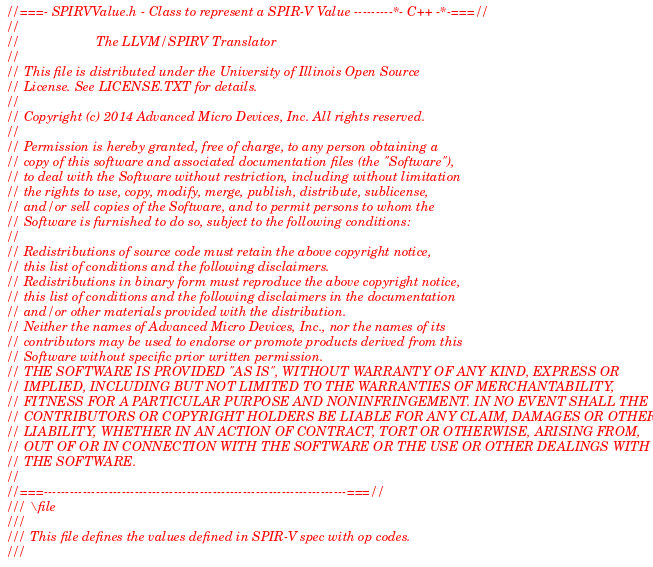Convert code to text. <code><loc_0><loc_0><loc_500><loc_500><_C_>//===- SPIRVValue.h - Class to represent a SPIR-V Value ---------*- C++ -*-===//
//
//                     The LLVM/SPIRV Translator
//
// This file is distributed under the University of Illinois Open Source
// License. See LICENSE.TXT for details.
//
// Copyright (c) 2014 Advanced Micro Devices, Inc. All rights reserved.
//
// Permission is hereby granted, free of charge, to any person obtaining a
// copy of this software and associated documentation files (the "Software"),
// to deal with the Software without restriction, including without limitation
// the rights to use, copy, modify, merge, publish, distribute, sublicense,
// and/or sell copies of the Software, and to permit persons to whom the
// Software is furnished to do so, subject to the following conditions:
//
// Redistributions of source code must retain the above copyright notice,
// this list of conditions and the following disclaimers.
// Redistributions in binary form must reproduce the above copyright notice,
// this list of conditions and the following disclaimers in the documentation
// and/or other materials provided with the distribution.
// Neither the names of Advanced Micro Devices, Inc., nor the names of its
// contributors may be used to endorse or promote products derived from this
// Software without specific prior written permission.
// THE SOFTWARE IS PROVIDED "AS IS", WITHOUT WARRANTY OF ANY KIND, EXPRESS OR
// IMPLIED, INCLUDING BUT NOT LIMITED TO THE WARRANTIES OF MERCHANTABILITY,
// FITNESS FOR A PARTICULAR PURPOSE AND NONINFRINGEMENT. IN NO EVENT SHALL THE
// CONTRIBUTORS OR COPYRIGHT HOLDERS BE LIABLE FOR ANY CLAIM, DAMAGES OR OTHER
// LIABILITY, WHETHER IN AN ACTION OF CONTRACT, TORT OR OTHERWISE, ARISING FROM,
// OUT OF OR IN CONNECTION WITH THE SOFTWARE OR THE USE OR OTHER DEALINGS WITH
// THE SOFTWARE.
//
//===----------------------------------------------------------------------===//
/// \file
///
/// This file defines the values defined in SPIR-V spec with op codes.
///</code> 